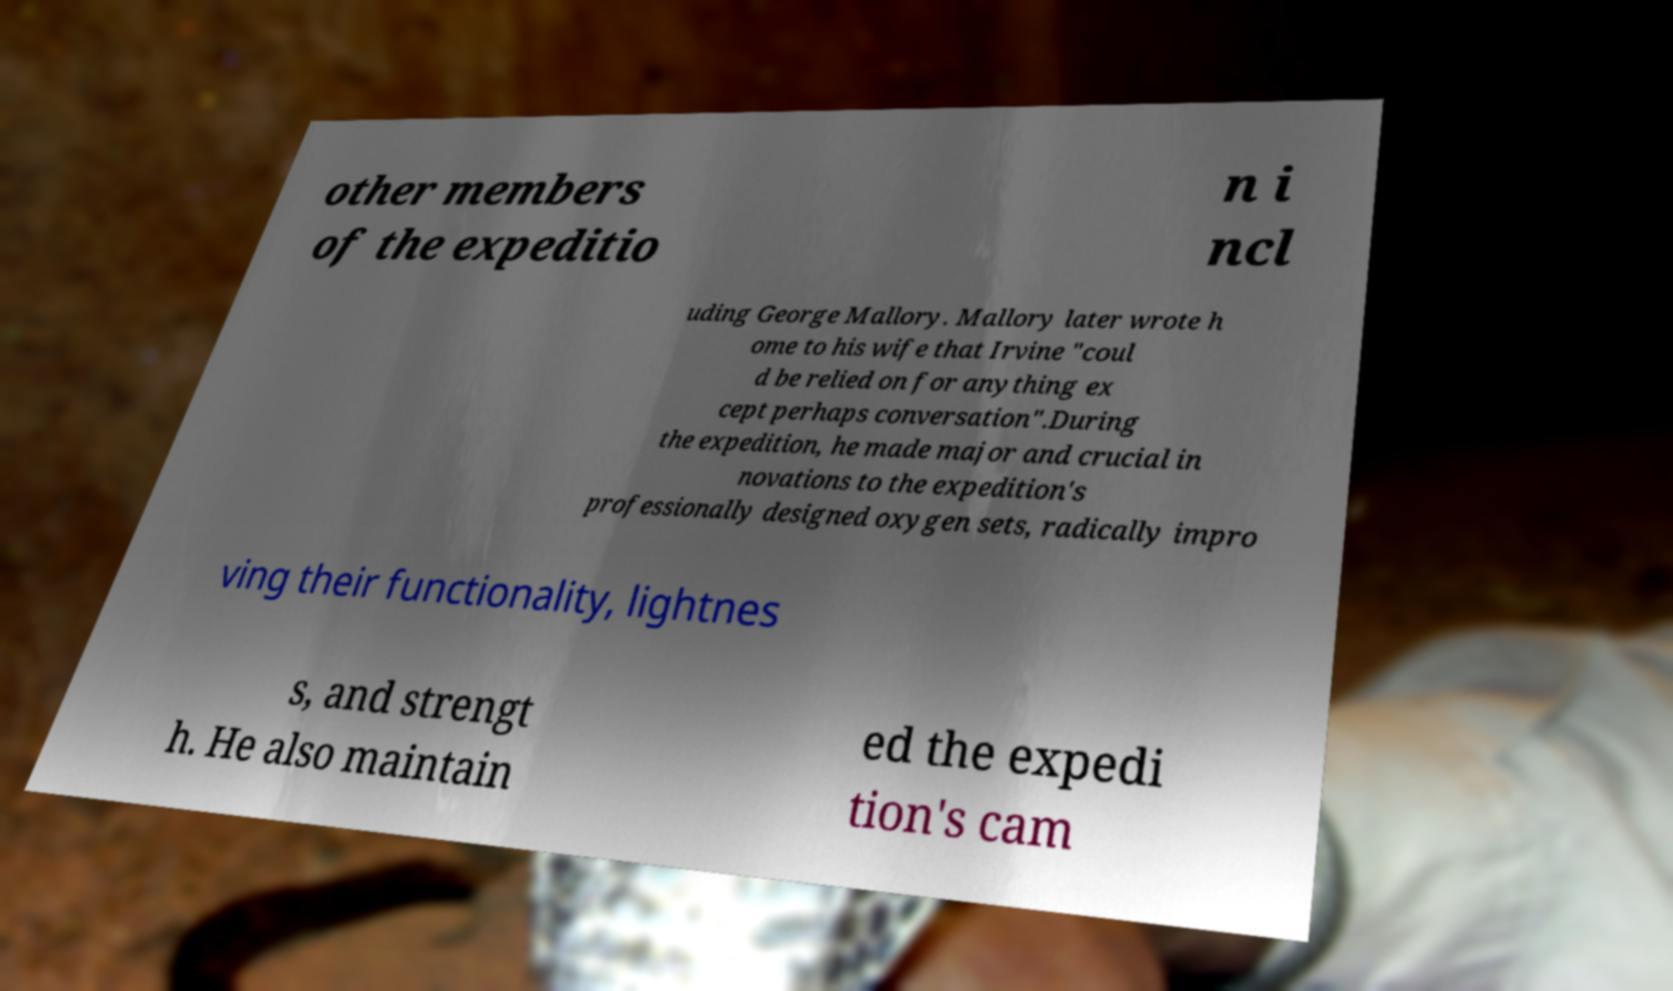What messages or text are displayed in this image? I need them in a readable, typed format. other members of the expeditio n i ncl uding George Mallory. Mallory later wrote h ome to his wife that Irvine "coul d be relied on for anything ex cept perhaps conversation".During the expedition, he made major and crucial in novations to the expedition's professionally designed oxygen sets, radically impro ving their functionality, lightnes s, and strengt h. He also maintain ed the expedi tion's cam 